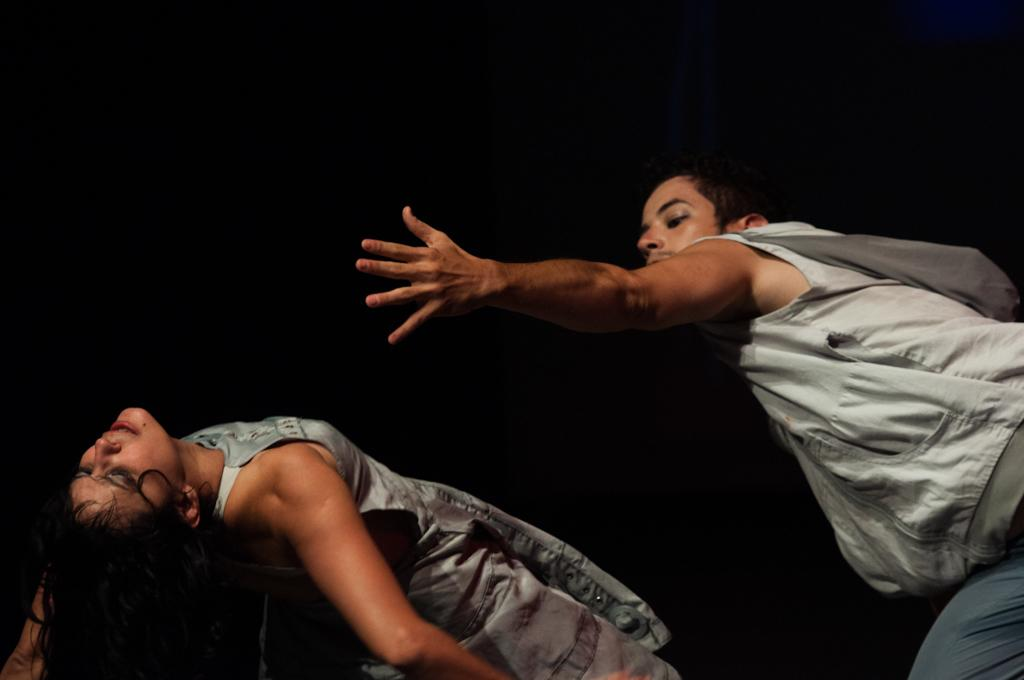How many people are in the image? There are two persons in the image. What can be observed about the background of the image? The background of the image is dark. What type of cracker is being used to increase the size of the stomach in the image? There is no cracker or stomach present in the image, so this question cannot be answered. 